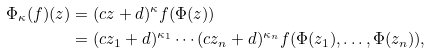Convert formula to latex. <formula><loc_0><loc_0><loc_500><loc_500>\Phi _ { \kappa } ( f ) ( z ) & = ( c z + d ) ^ { \kappa } f ( \Phi ( z ) ) \\ & = ( c z _ { 1 } + d ) ^ { \kappa _ { 1 } } \cdots ( c z _ { n } + d ) ^ { \kappa _ { n } } f ( \Phi ( z _ { 1 } ) , \dots , \Phi ( z _ { n } ) ) ,</formula> 